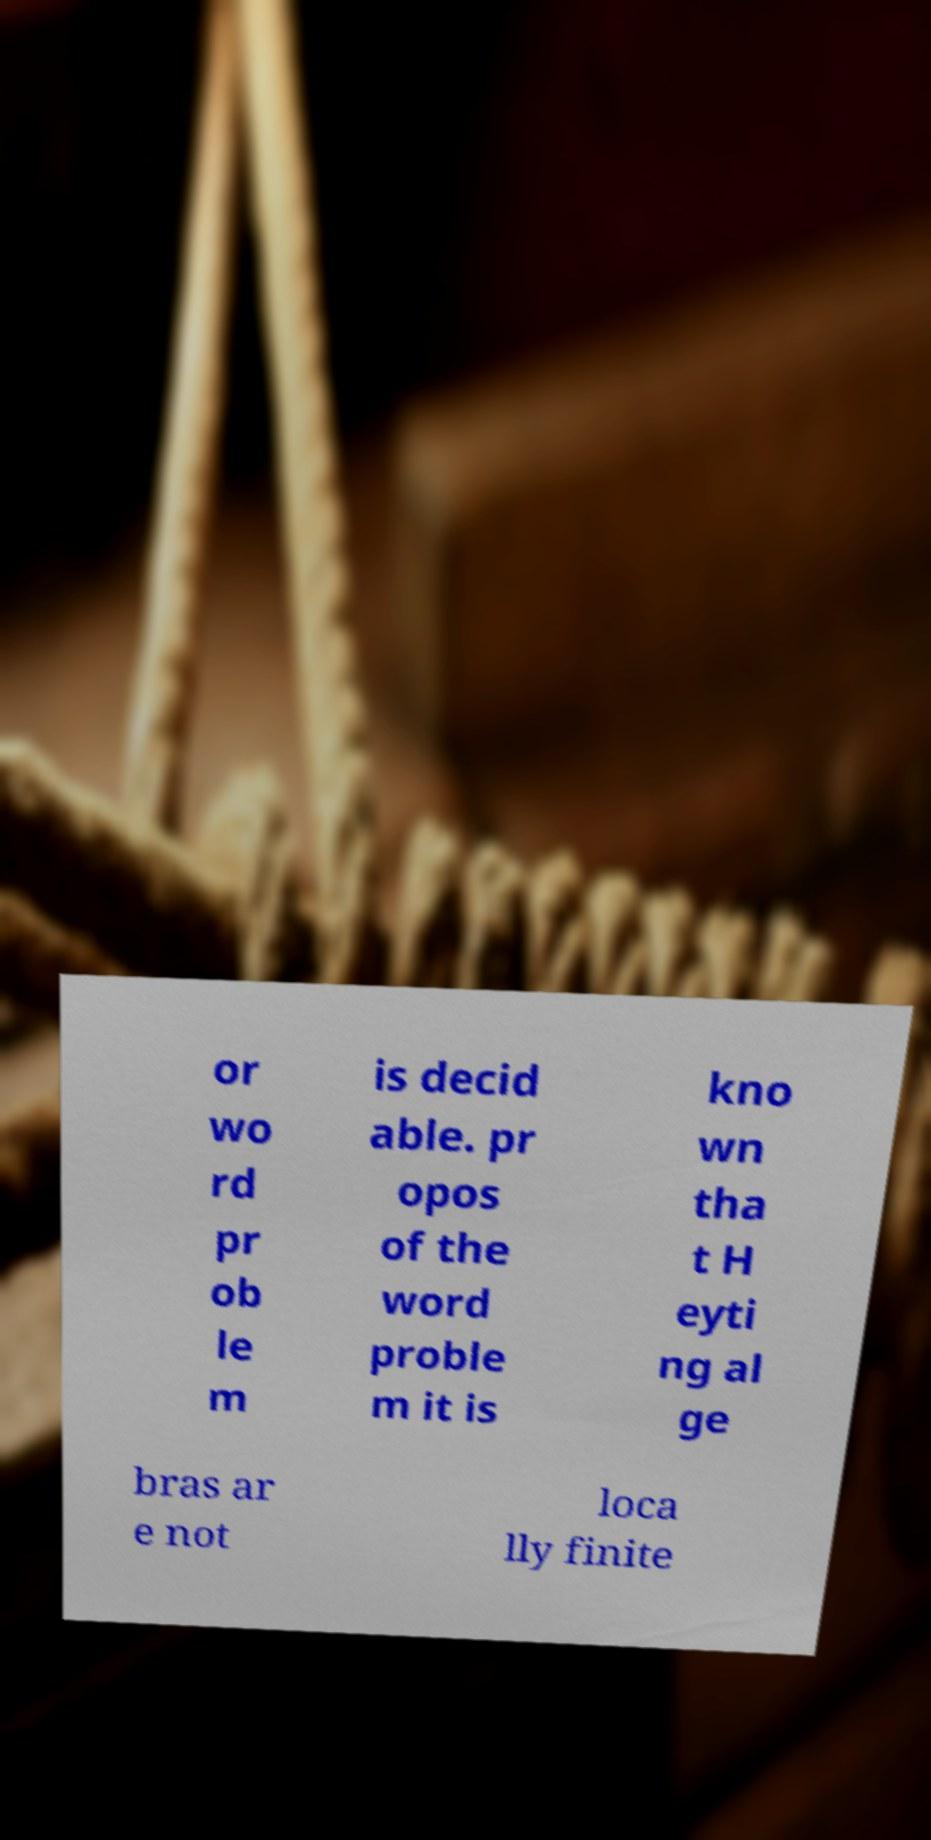I need the written content from this picture converted into text. Can you do that? or wo rd pr ob le m is decid able. pr opos of the word proble m it is kno wn tha t H eyti ng al ge bras ar e not loca lly finite 